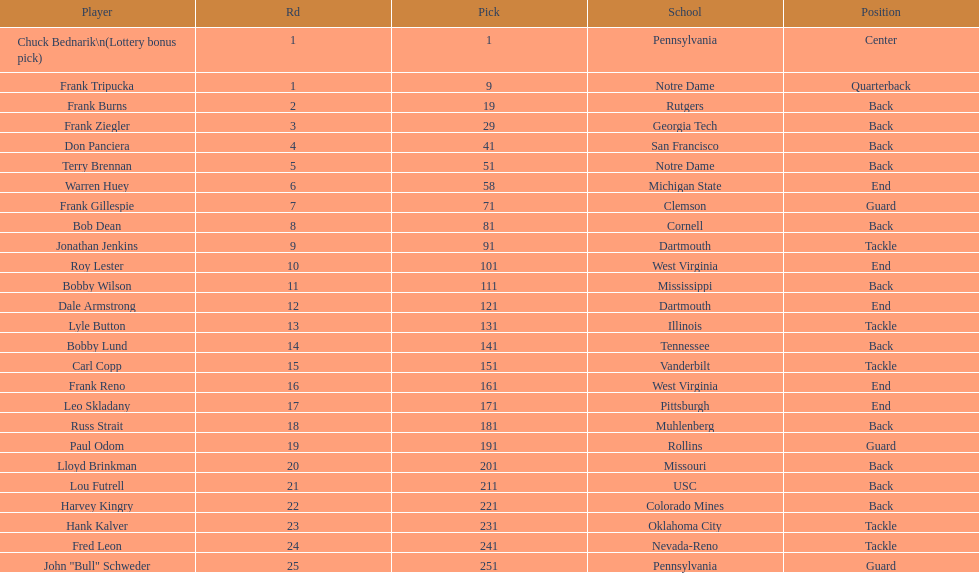How many players were from notre dame? 2. 